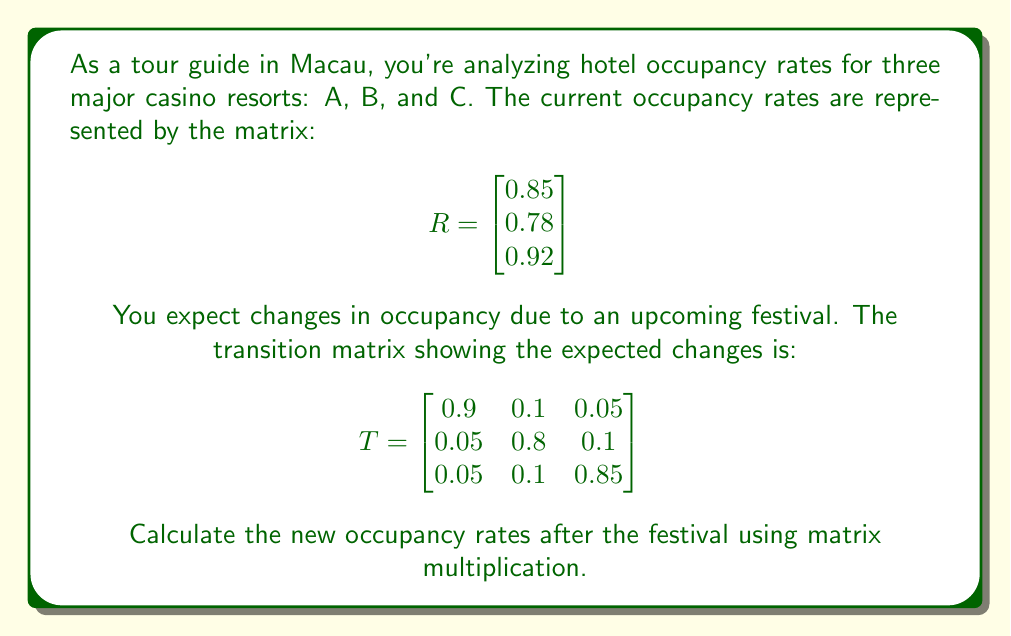What is the answer to this math problem? To solve this problem, we need to multiply the transition matrix T by the current occupancy rates matrix R. This will give us the new occupancy rates.

Step 1: Set up the matrix multiplication
$$TR = \begin{bmatrix} 
0.9 & 0.1 & 0.05 \\
0.05 & 0.8 & 0.1 \\
0.05 & 0.1 & 0.85
\end{bmatrix} \times \begin{bmatrix} 0.85 \\ 0.78 \\ 0.92 \end{bmatrix}$$

Step 2: Multiply each row of T by R
For the first row:
$$(0.9 \times 0.85) + (0.1 \times 0.78) + (0.05 \times 0.92) = 0.765 + 0.078 + 0.046 = 0.889$$

For the second row:
$$(0.05 \times 0.85) + (0.8 \times 0.78) + (0.1 \times 0.92) = 0.0425 + 0.624 + 0.092 = 0.7585$$

For the third row:
$$(0.05 \times 0.85) + (0.1 \times 0.78) + (0.85 \times 0.92) = 0.0425 + 0.078 + 0.782 = 0.9025$$

Step 3: Write the result as a new matrix
$$TR = \begin{bmatrix} 0.889 \\ 0.7585 \\ 0.9025 \end{bmatrix}$$

This matrix represents the new occupancy rates for hotels A, B, and C after the festival.
Answer: $$\begin{bmatrix} 0.889 \\ 0.7585 \\ 0.9025 \end{bmatrix}$$ 